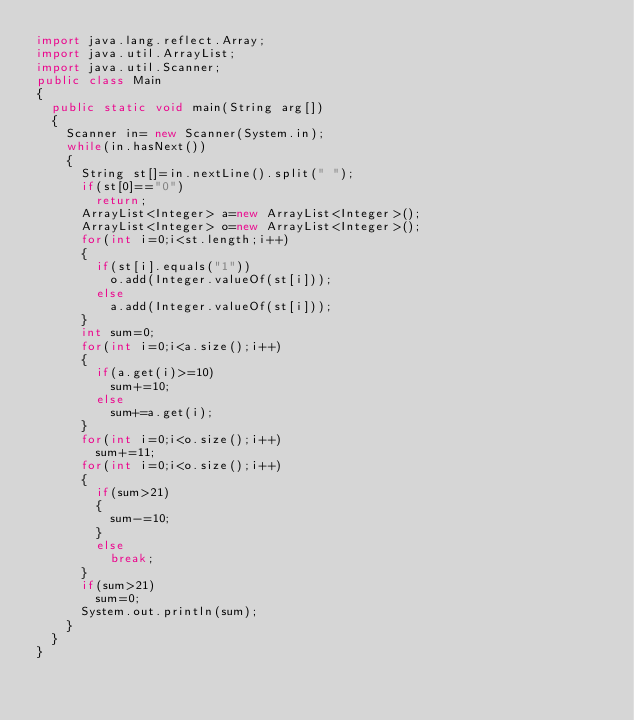<code> <loc_0><loc_0><loc_500><loc_500><_Java_>import java.lang.reflect.Array;
import java.util.ArrayList;
import java.util.Scanner;
public class Main 
{
	public static void main(String arg[])
	{
		Scanner in= new Scanner(System.in);
		while(in.hasNext())
		{
			String st[]=in.nextLine().split(" ");
			if(st[0]=="0")
				return;
			ArrayList<Integer> a=new ArrayList<Integer>();
			ArrayList<Integer> o=new ArrayList<Integer>();
			for(int i=0;i<st.length;i++)
			{
				if(st[i].equals("1"))
					o.add(Integer.valueOf(st[i]));
				else
					a.add(Integer.valueOf(st[i]));
			}	
			int sum=0;
			for(int i=0;i<a.size();i++)
			{
				if(a.get(i)>=10)
					sum+=10;
				else
					sum+=a.get(i);
			}
			for(int i=0;i<o.size();i++)
				sum+=11;
			for(int i=0;i<o.size();i++)
			{
				if(sum>21)
				{
					sum-=10;
				}
				else
					break;
			}
			if(sum>21)
				sum=0;
			System.out.println(sum);
		}
	}
}</code> 